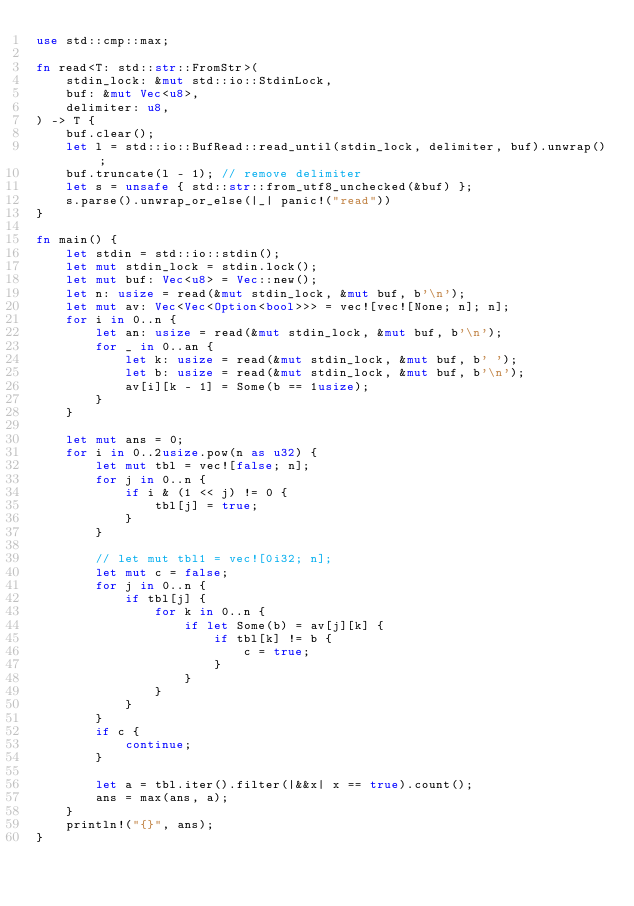Convert code to text. <code><loc_0><loc_0><loc_500><loc_500><_Rust_>use std::cmp::max;

fn read<T: std::str::FromStr>(
    stdin_lock: &mut std::io::StdinLock,
    buf: &mut Vec<u8>,
    delimiter: u8,
) -> T {
    buf.clear();
    let l = std::io::BufRead::read_until(stdin_lock, delimiter, buf).unwrap();
    buf.truncate(l - 1); // remove delimiter
    let s = unsafe { std::str::from_utf8_unchecked(&buf) };
    s.parse().unwrap_or_else(|_| panic!("read"))
}

fn main() {
    let stdin = std::io::stdin();
    let mut stdin_lock = stdin.lock();
    let mut buf: Vec<u8> = Vec::new();
    let n: usize = read(&mut stdin_lock, &mut buf, b'\n');
    let mut av: Vec<Vec<Option<bool>>> = vec![vec![None; n]; n];
    for i in 0..n {
        let an: usize = read(&mut stdin_lock, &mut buf, b'\n');
        for _ in 0..an {
            let k: usize = read(&mut stdin_lock, &mut buf, b' ');
            let b: usize = read(&mut stdin_lock, &mut buf, b'\n');
            av[i][k - 1] = Some(b == 1usize);
        }
    }

    let mut ans = 0;
    for i in 0..2usize.pow(n as u32) {
        let mut tbl = vec![false; n];
        for j in 0..n {
            if i & (1 << j) != 0 {
                tbl[j] = true;
            }
        }

        // let mut tbl1 = vec![0i32; n];
        let mut c = false;
        for j in 0..n {
            if tbl[j] {
                for k in 0..n {
                    if let Some(b) = av[j][k] {
                        if tbl[k] != b {
                            c = true;
                        }
                    }
                }
            }
        }
        if c {
            continue;
        }

        let a = tbl.iter().filter(|&&x| x == true).count();
        ans = max(ans, a);
    }
    println!("{}", ans);
}
</code> 